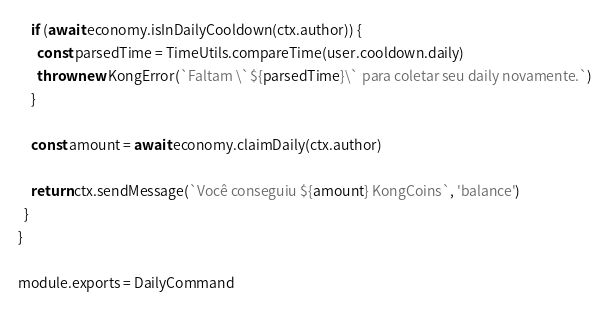Convert code to text. <code><loc_0><loc_0><loc_500><loc_500><_JavaScript_>    if (await economy.isInDailyCooldown(ctx.author)) {
      const parsedTime = TimeUtils.compareTime(user.cooldown.daily)
      throw new KongError(`Faltam \`${parsedTime}\` para coletar seu daily novamente.`)
    }

    const amount = await economy.claimDaily(ctx.author)

    return ctx.sendMessage(`Você conseguiu ${amount} KongCoins`, 'balance')
  }
}

module.exports = DailyCommand
</code> 